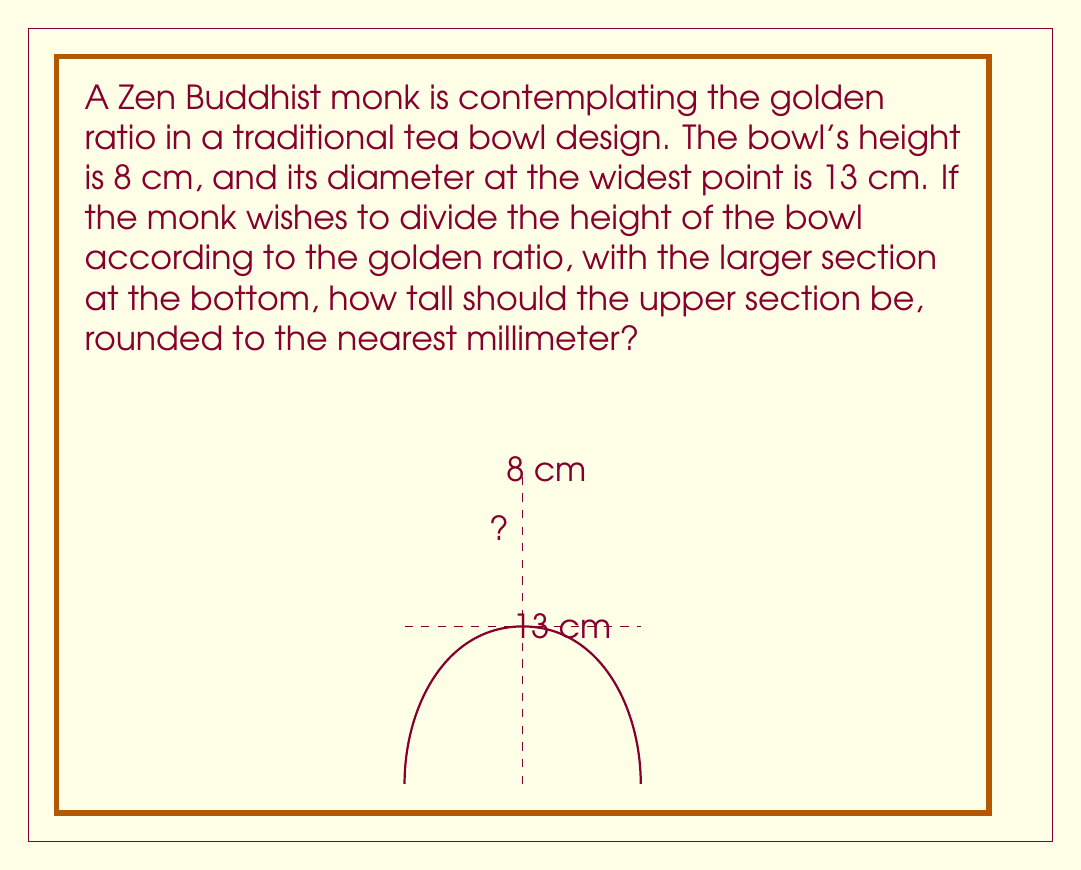Can you answer this question? To solve this problem, we need to use the properties of the golden ratio, which is approximately 1.618033988749895. Let's approach this step-by-step:

1) The golden ratio, often denoted by φ (phi), is defined as:

   $$\phi = \frac{a+b}{a} = \frac{a}{b}$$

   where $a$ is the longer segment and $b$ is the shorter segment.

2) In our case, the total height of the bowl is 8 cm. Let's call the height of the bottom section $x$. Then the height of the top section will be $(8-x)$ cm.

3) According to the golden ratio:

   $$\frac{8}{x} = \frac{x}{8-x}$$

4) Cross-multiplying:

   $$8(8-x) = x^2$$

5) Expanding:

   $$64 - 8x = x^2$$

6) Rearranging:

   $$x^2 + 8x - 64 = 0$$

7) This is a quadratic equation. We can solve it using the quadratic formula:

   $$x = \frac{-b \pm \sqrt{b^2 - 4ac}}{2a}$$

   where $a=1$, $b=8$, and $c=-64$

8) Plugging in these values:

   $$x = \frac{-8 \pm \sqrt{64 + 256}}{2} = \frac{-8 \pm \sqrt{320}}{2}$$

9) Simplifying:

   $$x = \frac{-8 \pm 17.88854382}{2}$$

10) This gives us two solutions:
    $x_1 = 4.94427191$ and $x_2 = -12.94427191$

11) Since we're dealing with physical measurements, we can discard the negative solution. Therefore, the height of the bottom section is approximately 4.94427191 cm.

12) The height of the top section is thus:
    $8 - 4.94427191 = 3.05572809$ cm

13) Rounding to the nearest millimeter:
    $3.05572809 \approx 3.056$ cm
Answer: The upper section of the tea bowl should be approximately 3.1 cm tall. 